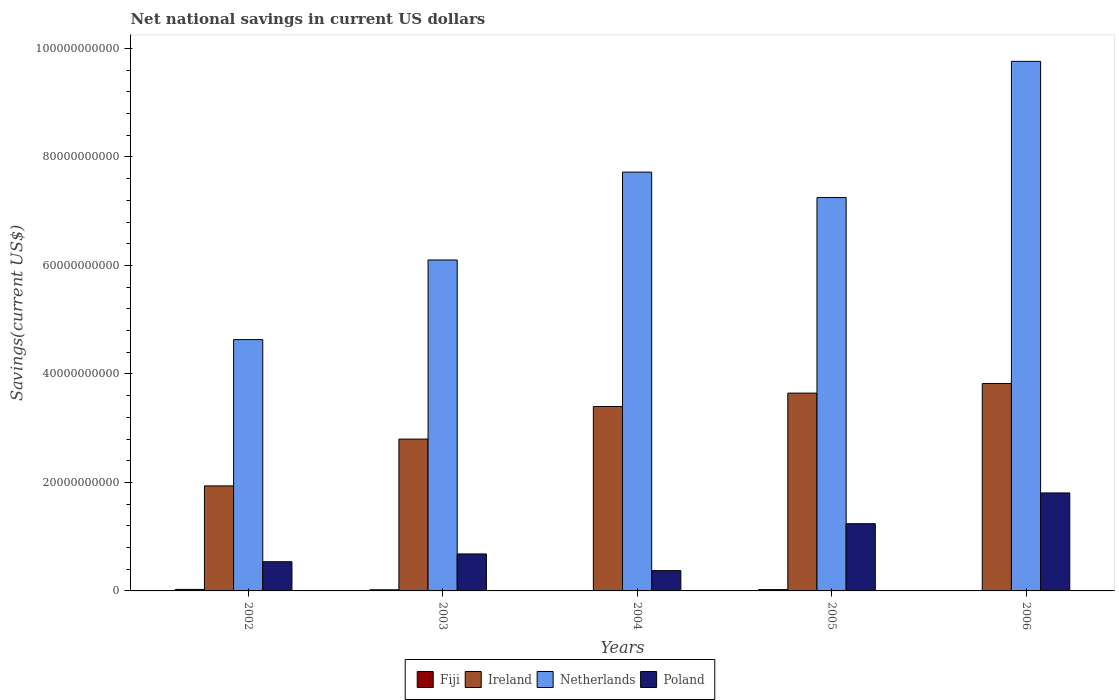How many different coloured bars are there?
Make the answer very short. 4. Are the number of bars on each tick of the X-axis equal?
Offer a very short reply. No. How many bars are there on the 5th tick from the left?
Your answer should be compact. 3. How many bars are there on the 1st tick from the right?
Ensure brevity in your answer.  3. In how many cases, is the number of bars for a given year not equal to the number of legend labels?
Provide a short and direct response. 2. Across all years, what is the maximum net national savings in Poland?
Your response must be concise. 1.81e+1. Across all years, what is the minimum net national savings in Netherlands?
Make the answer very short. 4.63e+1. In which year was the net national savings in Netherlands maximum?
Your answer should be very brief. 2006. What is the total net national savings in Netherlands in the graph?
Offer a terse response. 3.55e+11. What is the difference between the net national savings in Poland in 2003 and that in 2004?
Ensure brevity in your answer.  3.07e+09. What is the difference between the net national savings in Fiji in 2003 and the net national savings in Ireland in 2002?
Make the answer very short. -1.92e+1. What is the average net national savings in Poland per year?
Your answer should be very brief. 9.28e+09. In the year 2005, what is the difference between the net national savings in Ireland and net national savings in Netherlands?
Make the answer very short. -3.61e+1. In how many years, is the net national savings in Netherlands greater than 4000000000 US$?
Your response must be concise. 5. What is the ratio of the net national savings in Fiji in 2002 to that in 2005?
Provide a short and direct response. 1.14. What is the difference between the highest and the second highest net national savings in Netherlands?
Your answer should be very brief. 2.04e+1. What is the difference between the highest and the lowest net national savings in Ireland?
Offer a very short reply. 1.89e+1. In how many years, is the net national savings in Poland greater than the average net national savings in Poland taken over all years?
Give a very brief answer. 2. Is the sum of the net national savings in Netherlands in 2003 and 2004 greater than the maximum net national savings in Fiji across all years?
Ensure brevity in your answer.  Yes. Is it the case that in every year, the sum of the net national savings in Ireland and net national savings in Netherlands is greater than the net national savings in Poland?
Ensure brevity in your answer.  Yes. How many bars are there?
Ensure brevity in your answer.  18. Are the values on the major ticks of Y-axis written in scientific E-notation?
Offer a very short reply. No. Does the graph contain any zero values?
Your response must be concise. Yes. What is the title of the graph?
Give a very brief answer. Net national savings in current US dollars. What is the label or title of the X-axis?
Your response must be concise. Years. What is the label or title of the Y-axis?
Give a very brief answer. Savings(current US$). What is the Savings(current US$) of Fiji in 2002?
Your response must be concise. 2.77e+08. What is the Savings(current US$) in Ireland in 2002?
Provide a succinct answer. 1.94e+1. What is the Savings(current US$) of Netherlands in 2002?
Offer a terse response. 4.63e+1. What is the Savings(current US$) of Poland in 2002?
Keep it short and to the point. 5.38e+09. What is the Savings(current US$) of Fiji in 2003?
Make the answer very short. 2.09e+08. What is the Savings(current US$) of Ireland in 2003?
Ensure brevity in your answer.  2.80e+1. What is the Savings(current US$) of Netherlands in 2003?
Provide a short and direct response. 6.10e+1. What is the Savings(current US$) in Poland in 2003?
Your answer should be very brief. 6.82e+09. What is the Savings(current US$) of Fiji in 2004?
Ensure brevity in your answer.  0. What is the Savings(current US$) in Ireland in 2004?
Provide a succinct answer. 3.40e+1. What is the Savings(current US$) of Netherlands in 2004?
Offer a terse response. 7.72e+1. What is the Savings(current US$) in Poland in 2004?
Keep it short and to the point. 3.74e+09. What is the Savings(current US$) of Fiji in 2005?
Offer a very short reply. 2.43e+08. What is the Savings(current US$) of Ireland in 2005?
Give a very brief answer. 3.65e+1. What is the Savings(current US$) in Netherlands in 2005?
Make the answer very short. 7.25e+1. What is the Savings(current US$) in Poland in 2005?
Provide a short and direct response. 1.24e+1. What is the Savings(current US$) in Fiji in 2006?
Your response must be concise. 0. What is the Savings(current US$) of Ireland in 2006?
Provide a short and direct response. 3.82e+1. What is the Savings(current US$) of Netherlands in 2006?
Your response must be concise. 9.76e+1. What is the Savings(current US$) in Poland in 2006?
Provide a succinct answer. 1.81e+1. Across all years, what is the maximum Savings(current US$) of Fiji?
Provide a succinct answer. 2.77e+08. Across all years, what is the maximum Savings(current US$) of Ireland?
Your answer should be very brief. 3.82e+1. Across all years, what is the maximum Savings(current US$) of Netherlands?
Offer a very short reply. 9.76e+1. Across all years, what is the maximum Savings(current US$) of Poland?
Keep it short and to the point. 1.81e+1. Across all years, what is the minimum Savings(current US$) of Ireland?
Give a very brief answer. 1.94e+1. Across all years, what is the minimum Savings(current US$) in Netherlands?
Make the answer very short. 4.63e+1. Across all years, what is the minimum Savings(current US$) in Poland?
Offer a terse response. 3.74e+09. What is the total Savings(current US$) of Fiji in the graph?
Your answer should be very brief. 7.29e+08. What is the total Savings(current US$) of Ireland in the graph?
Provide a short and direct response. 1.56e+11. What is the total Savings(current US$) in Netherlands in the graph?
Offer a terse response. 3.55e+11. What is the total Savings(current US$) in Poland in the graph?
Your answer should be compact. 4.64e+1. What is the difference between the Savings(current US$) in Fiji in 2002 and that in 2003?
Provide a succinct answer. 6.84e+07. What is the difference between the Savings(current US$) of Ireland in 2002 and that in 2003?
Give a very brief answer. -8.63e+09. What is the difference between the Savings(current US$) of Netherlands in 2002 and that in 2003?
Keep it short and to the point. -1.47e+1. What is the difference between the Savings(current US$) of Poland in 2002 and that in 2003?
Your answer should be very brief. -1.43e+09. What is the difference between the Savings(current US$) of Ireland in 2002 and that in 2004?
Your answer should be very brief. -1.46e+1. What is the difference between the Savings(current US$) in Netherlands in 2002 and that in 2004?
Your answer should be compact. -3.09e+1. What is the difference between the Savings(current US$) in Poland in 2002 and that in 2004?
Your response must be concise. 1.64e+09. What is the difference between the Savings(current US$) in Fiji in 2002 and that in 2005?
Provide a short and direct response. 3.46e+07. What is the difference between the Savings(current US$) in Ireland in 2002 and that in 2005?
Your answer should be very brief. -1.71e+1. What is the difference between the Savings(current US$) in Netherlands in 2002 and that in 2005?
Your answer should be compact. -2.62e+1. What is the difference between the Savings(current US$) of Poland in 2002 and that in 2005?
Provide a short and direct response. -7.01e+09. What is the difference between the Savings(current US$) in Ireland in 2002 and that in 2006?
Keep it short and to the point. -1.89e+1. What is the difference between the Savings(current US$) of Netherlands in 2002 and that in 2006?
Provide a succinct answer. -5.13e+1. What is the difference between the Savings(current US$) in Poland in 2002 and that in 2006?
Your answer should be very brief. -1.27e+1. What is the difference between the Savings(current US$) of Ireland in 2003 and that in 2004?
Keep it short and to the point. -6.01e+09. What is the difference between the Savings(current US$) in Netherlands in 2003 and that in 2004?
Your answer should be compact. -1.62e+1. What is the difference between the Savings(current US$) of Poland in 2003 and that in 2004?
Your response must be concise. 3.07e+09. What is the difference between the Savings(current US$) in Fiji in 2003 and that in 2005?
Keep it short and to the point. -3.38e+07. What is the difference between the Savings(current US$) in Ireland in 2003 and that in 2005?
Offer a terse response. -8.47e+09. What is the difference between the Savings(current US$) of Netherlands in 2003 and that in 2005?
Provide a succinct answer. -1.15e+1. What is the difference between the Savings(current US$) of Poland in 2003 and that in 2005?
Provide a short and direct response. -5.58e+09. What is the difference between the Savings(current US$) of Ireland in 2003 and that in 2006?
Keep it short and to the point. -1.02e+1. What is the difference between the Savings(current US$) of Netherlands in 2003 and that in 2006?
Keep it short and to the point. -3.66e+1. What is the difference between the Savings(current US$) in Poland in 2003 and that in 2006?
Ensure brevity in your answer.  -1.12e+1. What is the difference between the Savings(current US$) in Ireland in 2004 and that in 2005?
Your answer should be compact. -2.46e+09. What is the difference between the Savings(current US$) of Netherlands in 2004 and that in 2005?
Ensure brevity in your answer.  4.68e+09. What is the difference between the Savings(current US$) in Poland in 2004 and that in 2005?
Keep it short and to the point. -8.65e+09. What is the difference between the Savings(current US$) in Ireland in 2004 and that in 2006?
Your response must be concise. -4.23e+09. What is the difference between the Savings(current US$) of Netherlands in 2004 and that in 2006?
Your answer should be compact. -2.04e+1. What is the difference between the Savings(current US$) in Poland in 2004 and that in 2006?
Give a very brief answer. -1.43e+1. What is the difference between the Savings(current US$) in Ireland in 2005 and that in 2006?
Offer a very short reply. -1.76e+09. What is the difference between the Savings(current US$) in Netherlands in 2005 and that in 2006?
Your answer should be very brief. -2.51e+1. What is the difference between the Savings(current US$) in Poland in 2005 and that in 2006?
Your answer should be very brief. -5.67e+09. What is the difference between the Savings(current US$) in Fiji in 2002 and the Savings(current US$) in Ireland in 2003?
Your response must be concise. -2.77e+1. What is the difference between the Savings(current US$) in Fiji in 2002 and the Savings(current US$) in Netherlands in 2003?
Offer a very short reply. -6.07e+1. What is the difference between the Savings(current US$) in Fiji in 2002 and the Savings(current US$) in Poland in 2003?
Your response must be concise. -6.54e+09. What is the difference between the Savings(current US$) in Ireland in 2002 and the Savings(current US$) in Netherlands in 2003?
Ensure brevity in your answer.  -4.16e+1. What is the difference between the Savings(current US$) in Ireland in 2002 and the Savings(current US$) in Poland in 2003?
Provide a succinct answer. 1.25e+1. What is the difference between the Savings(current US$) of Netherlands in 2002 and the Savings(current US$) of Poland in 2003?
Keep it short and to the point. 3.95e+1. What is the difference between the Savings(current US$) of Fiji in 2002 and the Savings(current US$) of Ireland in 2004?
Offer a terse response. -3.37e+1. What is the difference between the Savings(current US$) of Fiji in 2002 and the Savings(current US$) of Netherlands in 2004?
Offer a terse response. -7.69e+1. What is the difference between the Savings(current US$) of Fiji in 2002 and the Savings(current US$) of Poland in 2004?
Your answer should be very brief. -3.46e+09. What is the difference between the Savings(current US$) of Ireland in 2002 and the Savings(current US$) of Netherlands in 2004?
Offer a very short reply. -5.78e+1. What is the difference between the Savings(current US$) in Ireland in 2002 and the Savings(current US$) in Poland in 2004?
Your answer should be compact. 1.56e+1. What is the difference between the Savings(current US$) of Netherlands in 2002 and the Savings(current US$) of Poland in 2004?
Your answer should be very brief. 4.26e+1. What is the difference between the Savings(current US$) of Fiji in 2002 and the Savings(current US$) of Ireland in 2005?
Ensure brevity in your answer.  -3.62e+1. What is the difference between the Savings(current US$) of Fiji in 2002 and the Savings(current US$) of Netherlands in 2005?
Your response must be concise. -7.22e+1. What is the difference between the Savings(current US$) of Fiji in 2002 and the Savings(current US$) of Poland in 2005?
Provide a succinct answer. -1.21e+1. What is the difference between the Savings(current US$) of Ireland in 2002 and the Savings(current US$) of Netherlands in 2005?
Provide a succinct answer. -5.32e+1. What is the difference between the Savings(current US$) of Ireland in 2002 and the Savings(current US$) of Poland in 2005?
Provide a succinct answer. 6.97e+09. What is the difference between the Savings(current US$) of Netherlands in 2002 and the Savings(current US$) of Poland in 2005?
Your answer should be very brief. 3.39e+1. What is the difference between the Savings(current US$) of Fiji in 2002 and the Savings(current US$) of Ireland in 2006?
Offer a terse response. -3.80e+1. What is the difference between the Savings(current US$) of Fiji in 2002 and the Savings(current US$) of Netherlands in 2006?
Offer a very short reply. -9.73e+1. What is the difference between the Savings(current US$) of Fiji in 2002 and the Savings(current US$) of Poland in 2006?
Provide a succinct answer. -1.78e+1. What is the difference between the Savings(current US$) in Ireland in 2002 and the Savings(current US$) in Netherlands in 2006?
Your response must be concise. -7.83e+1. What is the difference between the Savings(current US$) of Ireland in 2002 and the Savings(current US$) of Poland in 2006?
Offer a very short reply. 1.30e+09. What is the difference between the Savings(current US$) in Netherlands in 2002 and the Savings(current US$) in Poland in 2006?
Give a very brief answer. 2.83e+1. What is the difference between the Savings(current US$) in Fiji in 2003 and the Savings(current US$) in Ireland in 2004?
Ensure brevity in your answer.  -3.38e+1. What is the difference between the Savings(current US$) in Fiji in 2003 and the Savings(current US$) in Netherlands in 2004?
Make the answer very short. -7.70e+1. What is the difference between the Savings(current US$) of Fiji in 2003 and the Savings(current US$) of Poland in 2004?
Provide a short and direct response. -3.53e+09. What is the difference between the Savings(current US$) in Ireland in 2003 and the Savings(current US$) in Netherlands in 2004?
Provide a short and direct response. -4.92e+1. What is the difference between the Savings(current US$) of Ireland in 2003 and the Savings(current US$) of Poland in 2004?
Offer a terse response. 2.43e+1. What is the difference between the Savings(current US$) of Netherlands in 2003 and the Savings(current US$) of Poland in 2004?
Ensure brevity in your answer.  5.73e+1. What is the difference between the Savings(current US$) of Fiji in 2003 and the Savings(current US$) of Ireland in 2005?
Your answer should be very brief. -3.63e+1. What is the difference between the Savings(current US$) in Fiji in 2003 and the Savings(current US$) in Netherlands in 2005?
Give a very brief answer. -7.23e+1. What is the difference between the Savings(current US$) of Fiji in 2003 and the Savings(current US$) of Poland in 2005?
Provide a succinct answer. -1.22e+1. What is the difference between the Savings(current US$) of Ireland in 2003 and the Savings(current US$) of Netherlands in 2005?
Your answer should be compact. -4.45e+1. What is the difference between the Savings(current US$) of Ireland in 2003 and the Savings(current US$) of Poland in 2005?
Provide a short and direct response. 1.56e+1. What is the difference between the Savings(current US$) of Netherlands in 2003 and the Savings(current US$) of Poland in 2005?
Provide a succinct answer. 4.86e+1. What is the difference between the Savings(current US$) in Fiji in 2003 and the Savings(current US$) in Ireland in 2006?
Offer a terse response. -3.80e+1. What is the difference between the Savings(current US$) of Fiji in 2003 and the Savings(current US$) of Netherlands in 2006?
Give a very brief answer. -9.74e+1. What is the difference between the Savings(current US$) in Fiji in 2003 and the Savings(current US$) in Poland in 2006?
Ensure brevity in your answer.  -1.79e+1. What is the difference between the Savings(current US$) of Ireland in 2003 and the Savings(current US$) of Netherlands in 2006?
Your answer should be very brief. -6.96e+1. What is the difference between the Savings(current US$) in Ireland in 2003 and the Savings(current US$) in Poland in 2006?
Provide a succinct answer. 9.93e+09. What is the difference between the Savings(current US$) in Netherlands in 2003 and the Savings(current US$) in Poland in 2006?
Provide a short and direct response. 4.29e+1. What is the difference between the Savings(current US$) of Ireland in 2004 and the Savings(current US$) of Netherlands in 2005?
Provide a short and direct response. -3.85e+1. What is the difference between the Savings(current US$) in Ireland in 2004 and the Savings(current US$) in Poland in 2005?
Offer a very short reply. 2.16e+1. What is the difference between the Savings(current US$) of Netherlands in 2004 and the Savings(current US$) of Poland in 2005?
Ensure brevity in your answer.  6.48e+1. What is the difference between the Savings(current US$) in Ireland in 2004 and the Savings(current US$) in Netherlands in 2006?
Give a very brief answer. -6.36e+1. What is the difference between the Savings(current US$) of Ireland in 2004 and the Savings(current US$) of Poland in 2006?
Offer a very short reply. 1.59e+1. What is the difference between the Savings(current US$) of Netherlands in 2004 and the Savings(current US$) of Poland in 2006?
Ensure brevity in your answer.  5.91e+1. What is the difference between the Savings(current US$) of Fiji in 2005 and the Savings(current US$) of Ireland in 2006?
Your answer should be very brief. -3.80e+1. What is the difference between the Savings(current US$) of Fiji in 2005 and the Savings(current US$) of Netherlands in 2006?
Give a very brief answer. -9.74e+1. What is the difference between the Savings(current US$) in Fiji in 2005 and the Savings(current US$) in Poland in 2006?
Your answer should be very brief. -1.78e+1. What is the difference between the Savings(current US$) of Ireland in 2005 and the Savings(current US$) of Netherlands in 2006?
Give a very brief answer. -6.12e+1. What is the difference between the Savings(current US$) of Ireland in 2005 and the Savings(current US$) of Poland in 2006?
Your response must be concise. 1.84e+1. What is the difference between the Savings(current US$) of Netherlands in 2005 and the Savings(current US$) of Poland in 2006?
Your answer should be very brief. 5.45e+1. What is the average Savings(current US$) of Fiji per year?
Your answer should be compact. 1.46e+08. What is the average Savings(current US$) in Ireland per year?
Offer a very short reply. 3.12e+1. What is the average Savings(current US$) in Netherlands per year?
Make the answer very short. 7.09e+1. What is the average Savings(current US$) in Poland per year?
Offer a terse response. 9.28e+09. In the year 2002, what is the difference between the Savings(current US$) in Fiji and Savings(current US$) in Ireland?
Offer a very short reply. -1.91e+1. In the year 2002, what is the difference between the Savings(current US$) of Fiji and Savings(current US$) of Netherlands?
Provide a short and direct response. -4.61e+1. In the year 2002, what is the difference between the Savings(current US$) of Fiji and Savings(current US$) of Poland?
Your response must be concise. -5.10e+09. In the year 2002, what is the difference between the Savings(current US$) in Ireland and Savings(current US$) in Netherlands?
Your response must be concise. -2.70e+1. In the year 2002, what is the difference between the Savings(current US$) in Ireland and Savings(current US$) in Poland?
Offer a very short reply. 1.40e+1. In the year 2002, what is the difference between the Savings(current US$) of Netherlands and Savings(current US$) of Poland?
Your answer should be compact. 4.10e+1. In the year 2003, what is the difference between the Savings(current US$) in Fiji and Savings(current US$) in Ireland?
Keep it short and to the point. -2.78e+1. In the year 2003, what is the difference between the Savings(current US$) in Fiji and Savings(current US$) in Netherlands?
Your response must be concise. -6.08e+1. In the year 2003, what is the difference between the Savings(current US$) in Fiji and Savings(current US$) in Poland?
Keep it short and to the point. -6.61e+09. In the year 2003, what is the difference between the Savings(current US$) of Ireland and Savings(current US$) of Netherlands?
Provide a succinct answer. -3.30e+1. In the year 2003, what is the difference between the Savings(current US$) of Ireland and Savings(current US$) of Poland?
Provide a succinct answer. 2.12e+1. In the year 2003, what is the difference between the Savings(current US$) of Netherlands and Savings(current US$) of Poland?
Ensure brevity in your answer.  5.42e+1. In the year 2004, what is the difference between the Savings(current US$) in Ireland and Savings(current US$) in Netherlands?
Provide a succinct answer. -4.32e+1. In the year 2004, what is the difference between the Savings(current US$) of Ireland and Savings(current US$) of Poland?
Offer a very short reply. 3.03e+1. In the year 2004, what is the difference between the Savings(current US$) of Netherlands and Savings(current US$) of Poland?
Keep it short and to the point. 7.35e+1. In the year 2005, what is the difference between the Savings(current US$) in Fiji and Savings(current US$) in Ireland?
Your answer should be compact. -3.62e+1. In the year 2005, what is the difference between the Savings(current US$) of Fiji and Savings(current US$) of Netherlands?
Offer a very short reply. -7.23e+1. In the year 2005, what is the difference between the Savings(current US$) of Fiji and Savings(current US$) of Poland?
Offer a terse response. -1.22e+1. In the year 2005, what is the difference between the Savings(current US$) of Ireland and Savings(current US$) of Netherlands?
Your answer should be very brief. -3.61e+1. In the year 2005, what is the difference between the Savings(current US$) in Ireland and Savings(current US$) in Poland?
Your answer should be compact. 2.41e+1. In the year 2005, what is the difference between the Savings(current US$) of Netherlands and Savings(current US$) of Poland?
Your response must be concise. 6.01e+1. In the year 2006, what is the difference between the Savings(current US$) in Ireland and Savings(current US$) in Netherlands?
Give a very brief answer. -5.94e+1. In the year 2006, what is the difference between the Savings(current US$) in Ireland and Savings(current US$) in Poland?
Offer a terse response. 2.02e+1. In the year 2006, what is the difference between the Savings(current US$) in Netherlands and Savings(current US$) in Poland?
Give a very brief answer. 7.96e+1. What is the ratio of the Savings(current US$) of Fiji in 2002 to that in 2003?
Your answer should be very brief. 1.33. What is the ratio of the Savings(current US$) in Ireland in 2002 to that in 2003?
Provide a succinct answer. 0.69. What is the ratio of the Savings(current US$) of Netherlands in 2002 to that in 2003?
Make the answer very short. 0.76. What is the ratio of the Savings(current US$) of Poland in 2002 to that in 2003?
Keep it short and to the point. 0.79. What is the ratio of the Savings(current US$) of Ireland in 2002 to that in 2004?
Your response must be concise. 0.57. What is the ratio of the Savings(current US$) of Netherlands in 2002 to that in 2004?
Your response must be concise. 0.6. What is the ratio of the Savings(current US$) in Poland in 2002 to that in 2004?
Provide a succinct answer. 1.44. What is the ratio of the Savings(current US$) of Fiji in 2002 to that in 2005?
Your answer should be compact. 1.14. What is the ratio of the Savings(current US$) in Ireland in 2002 to that in 2005?
Your answer should be compact. 0.53. What is the ratio of the Savings(current US$) in Netherlands in 2002 to that in 2005?
Your answer should be very brief. 0.64. What is the ratio of the Savings(current US$) in Poland in 2002 to that in 2005?
Give a very brief answer. 0.43. What is the ratio of the Savings(current US$) in Ireland in 2002 to that in 2006?
Provide a short and direct response. 0.51. What is the ratio of the Savings(current US$) in Netherlands in 2002 to that in 2006?
Offer a very short reply. 0.47. What is the ratio of the Savings(current US$) in Poland in 2002 to that in 2006?
Provide a succinct answer. 0.3. What is the ratio of the Savings(current US$) of Ireland in 2003 to that in 2004?
Provide a short and direct response. 0.82. What is the ratio of the Savings(current US$) in Netherlands in 2003 to that in 2004?
Your answer should be compact. 0.79. What is the ratio of the Savings(current US$) in Poland in 2003 to that in 2004?
Ensure brevity in your answer.  1.82. What is the ratio of the Savings(current US$) of Fiji in 2003 to that in 2005?
Your answer should be compact. 0.86. What is the ratio of the Savings(current US$) of Ireland in 2003 to that in 2005?
Your answer should be very brief. 0.77. What is the ratio of the Savings(current US$) of Netherlands in 2003 to that in 2005?
Your response must be concise. 0.84. What is the ratio of the Savings(current US$) in Poland in 2003 to that in 2005?
Give a very brief answer. 0.55. What is the ratio of the Savings(current US$) of Ireland in 2003 to that in 2006?
Offer a very short reply. 0.73. What is the ratio of the Savings(current US$) in Netherlands in 2003 to that in 2006?
Give a very brief answer. 0.62. What is the ratio of the Savings(current US$) of Poland in 2003 to that in 2006?
Your response must be concise. 0.38. What is the ratio of the Savings(current US$) of Ireland in 2004 to that in 2005?
Provide a succinct answer. 0.93. What is the ratio of the Savings(current US$) in Netherlands in 2004 to that in 2005?
Your answer should be very brief. 1.06. What is the ratio of the Savings(current US$) of Poland in 2004 to that in 2005?
Offer a terse response. 0.3. What is the ratio of the Savings(current US$) in Ireland in 2004 to that in 2006?
Make the answer very short. 0.89. What is the ratio of the Savings(current US$) in Netherlands in 2004 to that in 2006?
Provide a short and direct response. 0.79. What is the ratio of the Savings(current US$) in Poland in 2004 to that in 2006?
Ensure brevity in your answer.  0.21. What is the ratio of the Savings(current US$) in Ireland in 2005 to that in 2006?
Your answer should be very brief. 0.95. What is the ratio of the Savings(current US$) of Netherlands in 2005 to that in 2006?
Make the answer very short. 0.74. What is the ratio of the Savings(current US$) of Poland in 2005 to that in 2006?
Provide a short and direct response. 0.69. What is the difference between the highest and the second highest Savings(current US$) of Fiji?
Keep it short and to the point. 3.46e+07. What is the difference between the highest and the second highest Savings(current US$) of Ireland?
Your answer should be compact. 1.76e+09. What is the difference between the highest and the second highest Savings(current US$) of Netherlands?
Make the answer very short. 2.04e+1. What is the difference between the highest and the second highest Savings(current US$) in Poland?
Your answer should be compact. 5.67e+09. What is the difference between the highest and the lowest Savings(current US$) in Fiji?
Ensure brevity in your answer.  2.77e+08. What is the difference between the highest and the lowest Savings(current US$) of Ireland?
Ensure brevity in your answer.  1.89e+1. What is the difference between the highest and the lowest Savings(current US$) in Netherlands?
Make the answer very short. 5.13e+1. What is the difference between the highest and the lowest Savings(current US$) in Poland?
Give a very brief answer. 1.43e+1. 